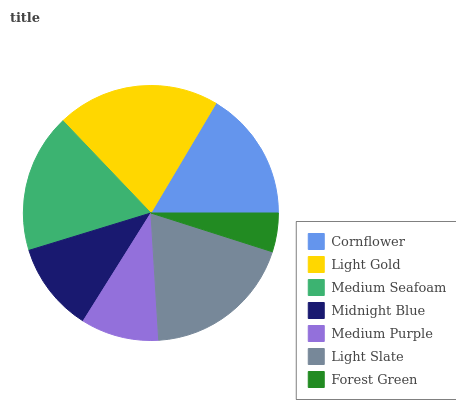Is Forest Green the minimum?
Answer yes or no. Yes. Is Light Gold the maximum?
Answer yes or no. Yes. Is Medium Seafoam the minimum?
Answer yes or no. No. Is Medium Seafoam the maximum?
Answer yes or no. No. Is Light Gold greater than Medium Seafoam?
Answer yes or no. Yes. Is Medium Seafoam less than Light Gold?
Answer yes or no. Yes. Is Medium Seafoam greater than Light Gold?
Answer yes or no. No. Is Light Gold less than Medium Seafoam?
Answer yes or no. No. Is Cornflower the high median?
Answer yes or no. Yes. Is Cornflower the low median?
Answer yes or no. Yes. Is Light Slate the high median?
Answer yes or no. No. Is Light Slate the low median?
Answer yes or no. No. 